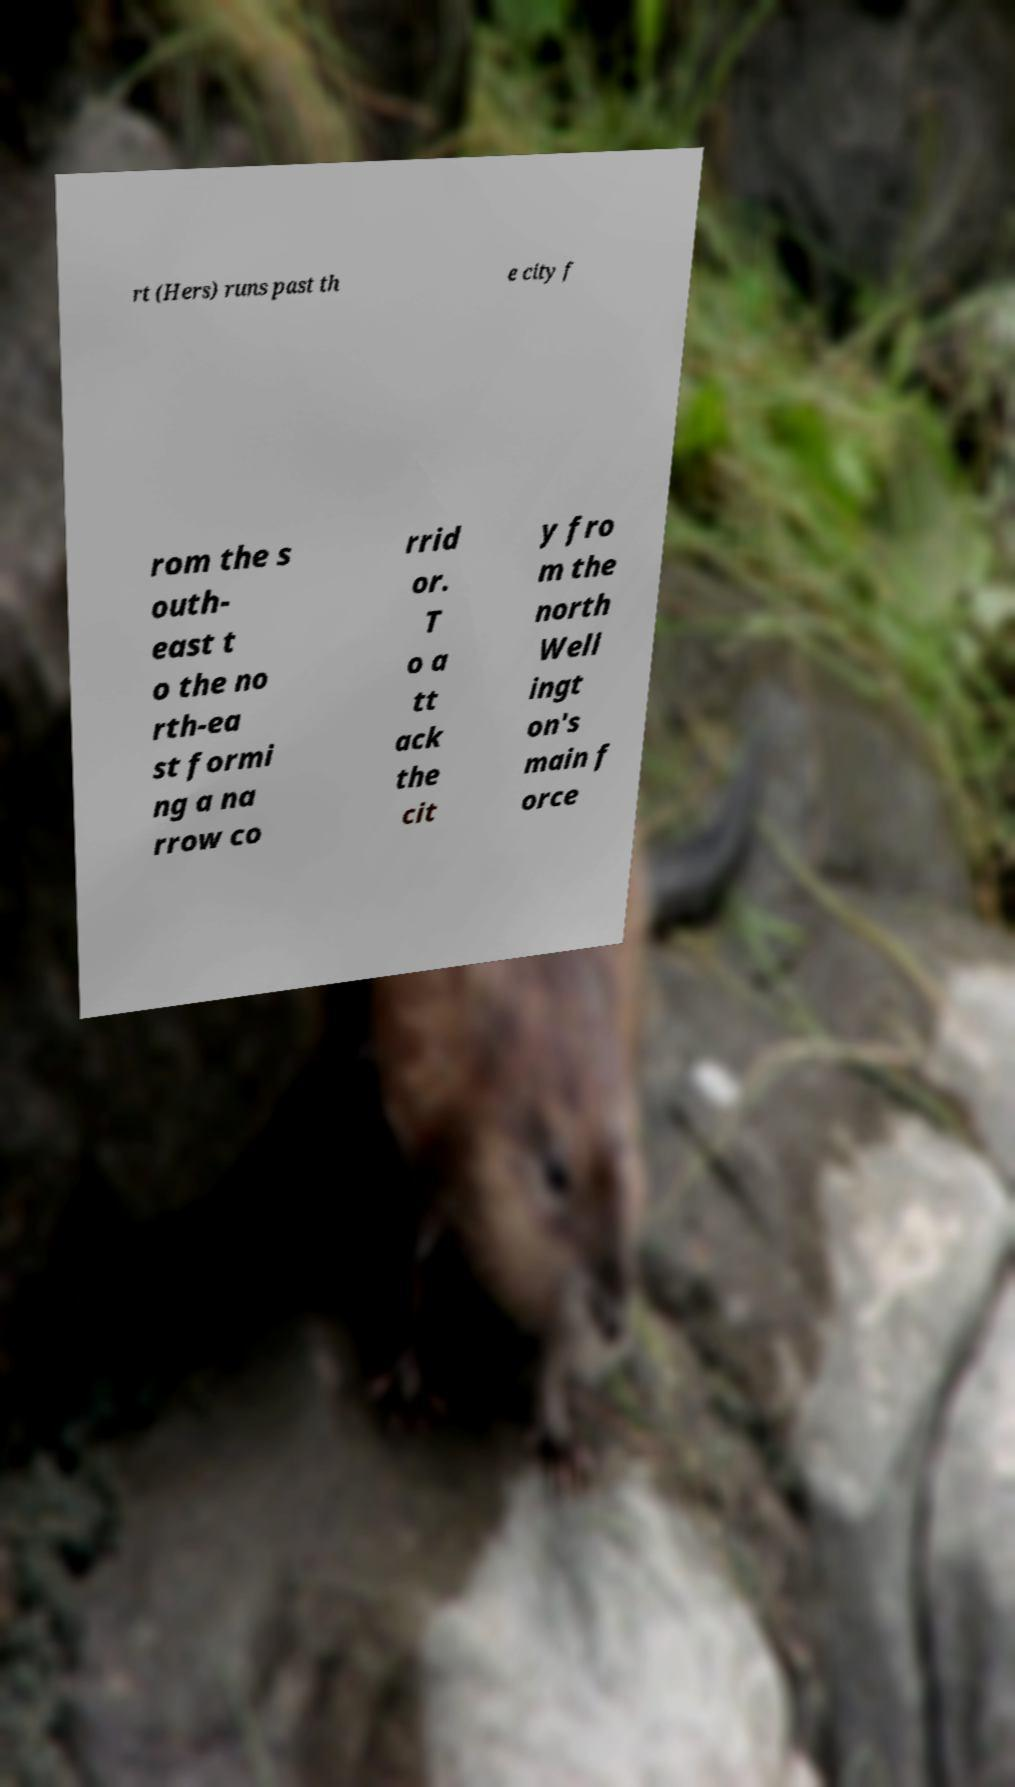For documentation purposes, I need the text within this image transcribed. Could you provide that? rt (Hers) runs past th e city f rom the s outh- east t o the no rth-ea st formi ng a na rrow co rrid or. T o a tt ack the cit y fro m the north Well ingt on's main f orce 